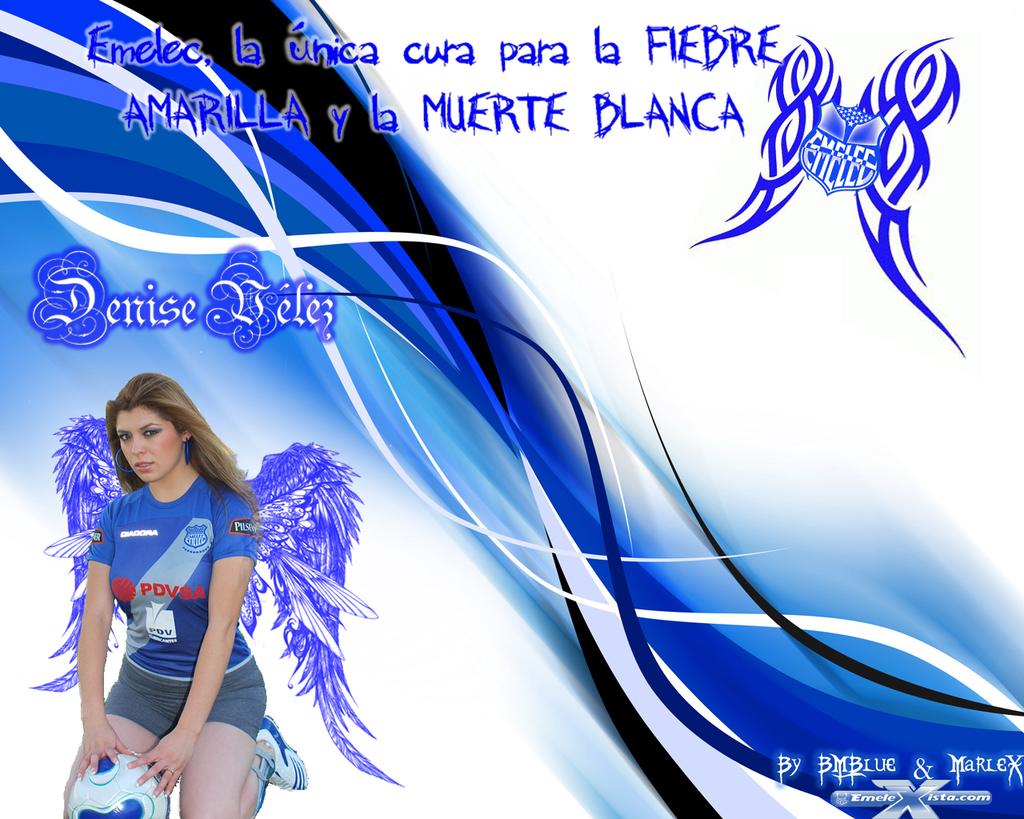What is the last letter to the left of the design?
Provide a short and direct response. A. 